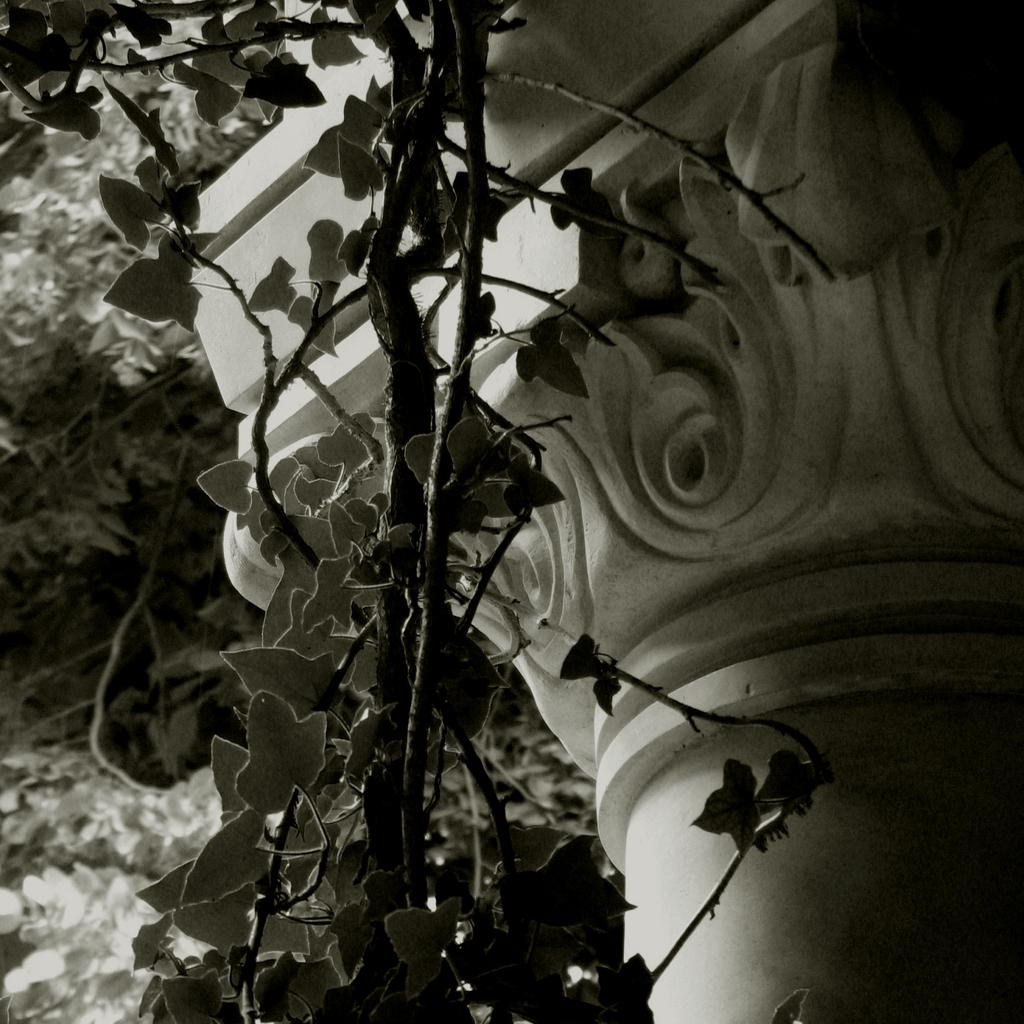What celestial bodies are depicted in the image? There are planets in the image. What type of structure can be seen in the image? There is a pillar in the image. What type of pet is visible in the image? There is no pet present in the image. What emotion is being expressed by the planets in the image? The planets do not express emotions, as they are celestial bodies and not living beings. 